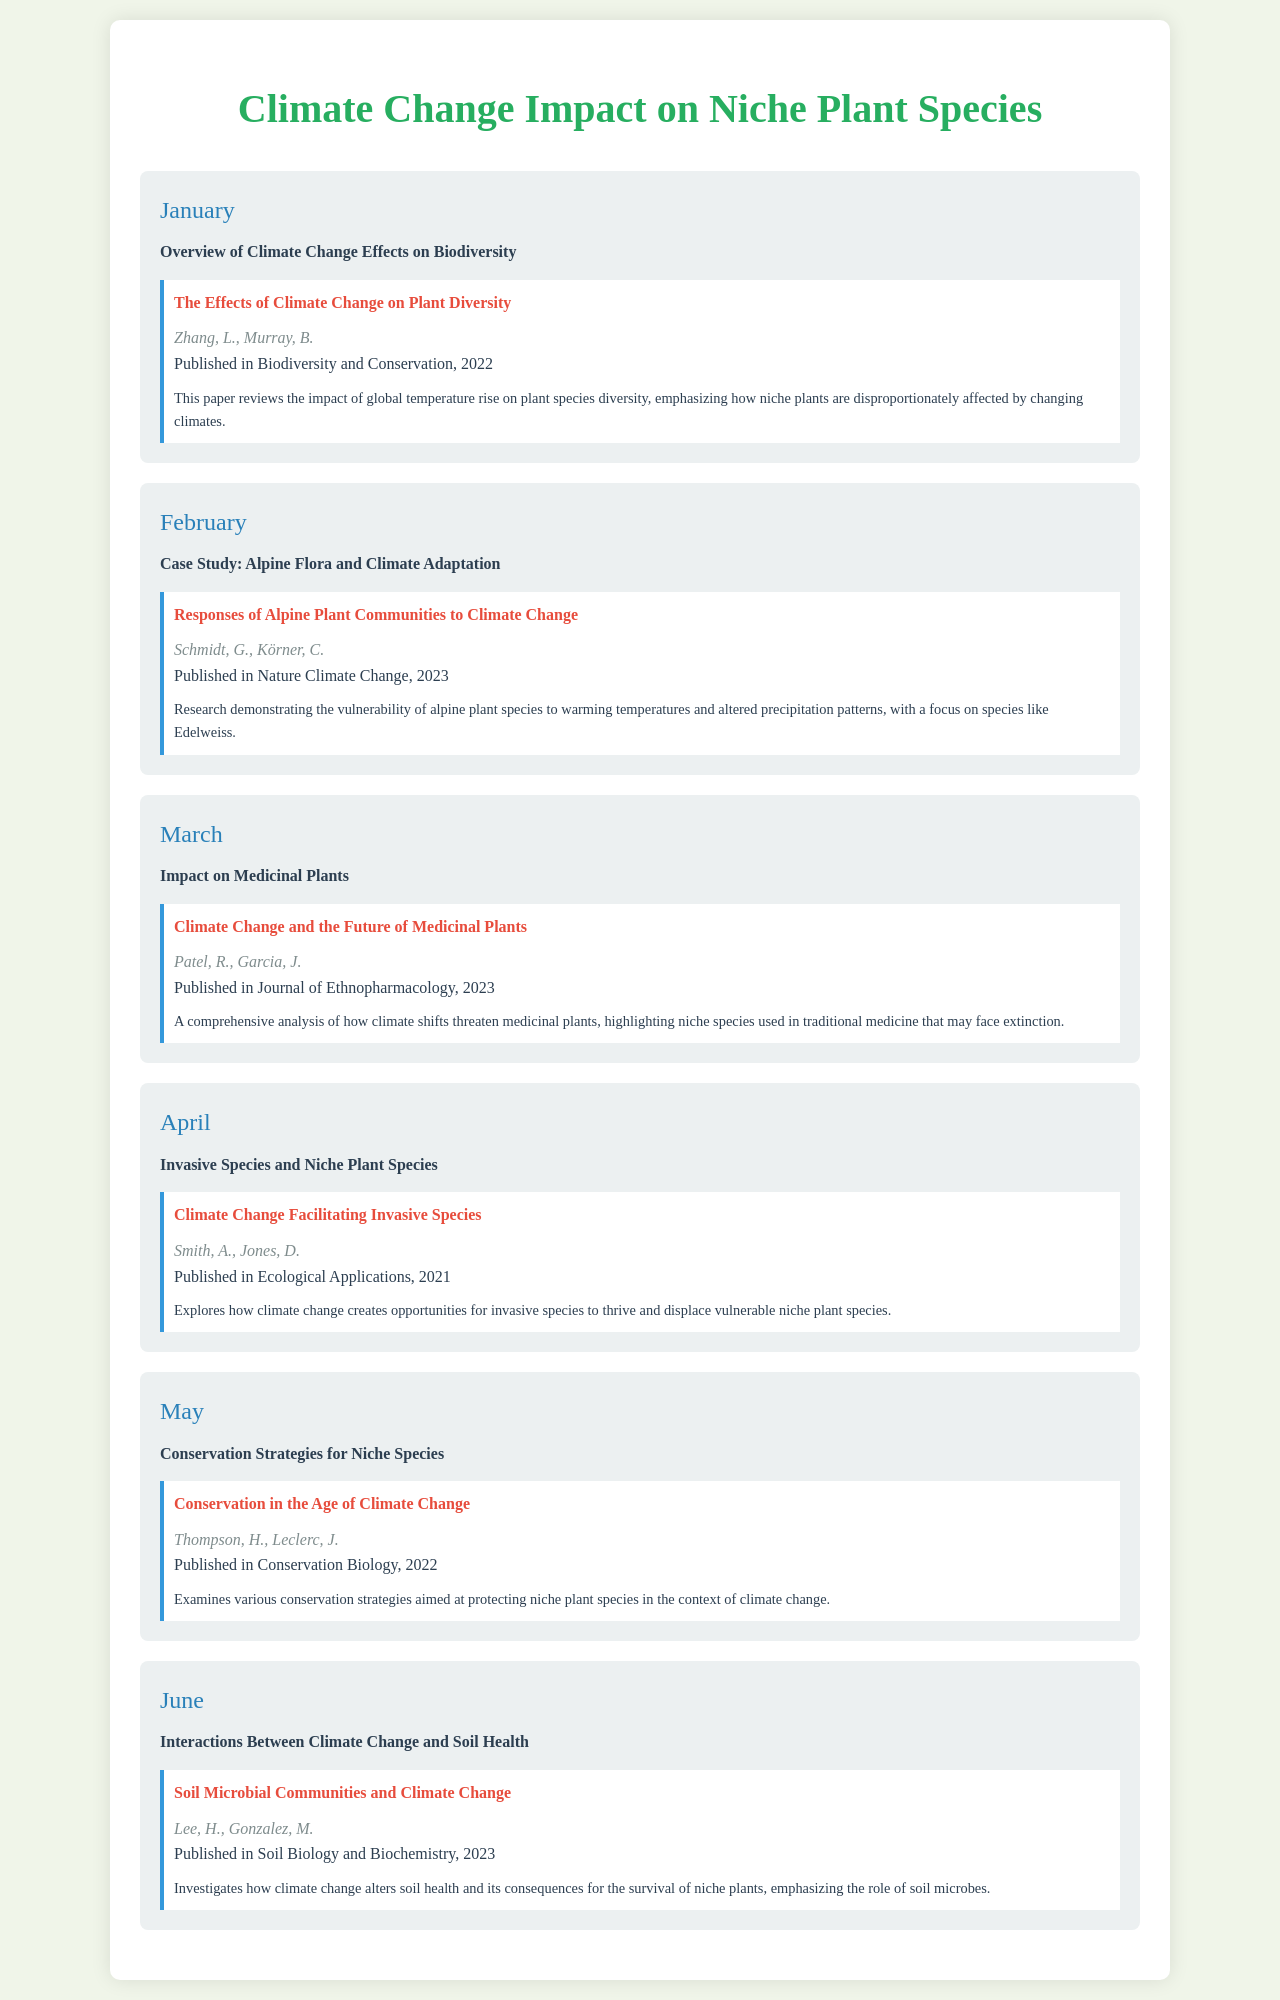what is the title of the document? The title of the document is stated in the header section of the rendered document.
Answer: Climate Change Impact on Niche Plant Species who authored the February literature review? The authors of the February literature review are listed under the respective month’s literature section.
Answer: Schmidt, G., Körner, C in which month is the topic "Impact on Medicinal Plants" addressed? The schedule outlines the topics associated with each month, and this particular topic is listed for March.
Answer: March what is the publication year of the article regarding invasive species? The publication year is indicated within the literature section for the relevant month.
Answer: 2021 what is the main focus of the April topic? The main focus is derived from the description provided under the respective month in the document.
Answer: Invasive Species and Niche Plant Species how many months are covered in the document? The number of months can be counted from the number of month cards presented.
Answer: Six what do the summaries typically highlight? The summaries consistently describe the main findings or conclusions from the referenced literature.
Answer: Impacts of climate change on niche plant species which journal published the article by Patel and Garcia? The journal where the article was published is specified under the literature section for March.
Answer: Journal of Ethnopharmacology 